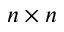<formula> <loc_0><loc_0><loc_500><loc_500>n \times n</formula> 